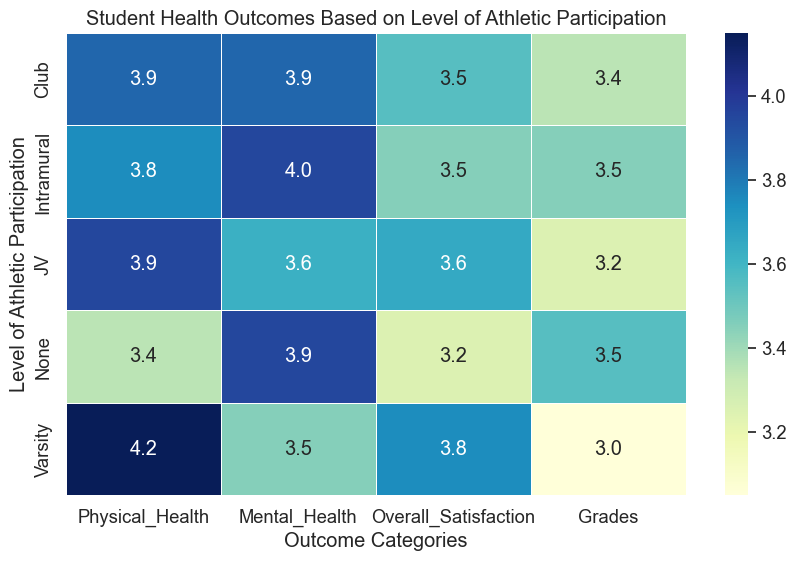Which level of athletic participation has the highest average physical health score? By examining the heatmap, the Varsity level shows the highest average physical health score with a value of 4.2.
Answer: Varsity Which level has the lowest average grades? The heatmap indicates that the Varsity level has the lowest average grades with a value of 3.0.
Answer: Varsity What is the difference between the average overall satisfaction for none and varsity participants? According to the heatmap, the overall satisfaction for none is 3.25 and for varsity is 3.75. The difference is 3.75 - 3.25 = 0.5
Answer: 0.5 Which level shows the highest mental health outcome? The none level shows the highest mental health outcome with a score of 4.0.
Answer: None How does the physical health of Club participants compare to that of Intramural participants? The heatmap reveals that the average physical health of Club participants is 3.85, which is higher than the Intramural participants' average physical health of 3.75.
Answer: Club participants have higher physical health Is the overall satisfaction for JV participants higher than intramural participants? According to the heatmap, the overall satisfaction for JV participants is 3.65 and for Intramural participants is 3.42. So, JV participants have a higher overall satisfaction.
Answer: Yes Which level shows the widest range in mental health scores? By comparing the scores, the none level has the widest range in mental health scores from 3.75 to 4.2, which gives a range of 0.45.
Answer: None What is the average physical health score for all levels combined? Summing up the physical health scores (3.35 + 3.75 + 3.85 + 3.95 + 4.2) and dividing by the number of levels (5) gives the average physical health score. (3.35 + 3.75 + 3.85 + 3.95 + 4.2) / 5 = 3.82
Answer: 3.82 Which level shows a better average performance in both grades and physical health? Looking at the heatmap, none level with grades 3.6 and physical health 3.35 has a better average combined performance in both categories compared to other levels.
Answer: None Does higher participation in athletics correlate with higher overall satisfaction? Yes, according to the heatmap, as the level of athletic participation increases from none to varsity, the overall satisfaction score also increases from 3.25 to 3.75.
Answer: Yes 